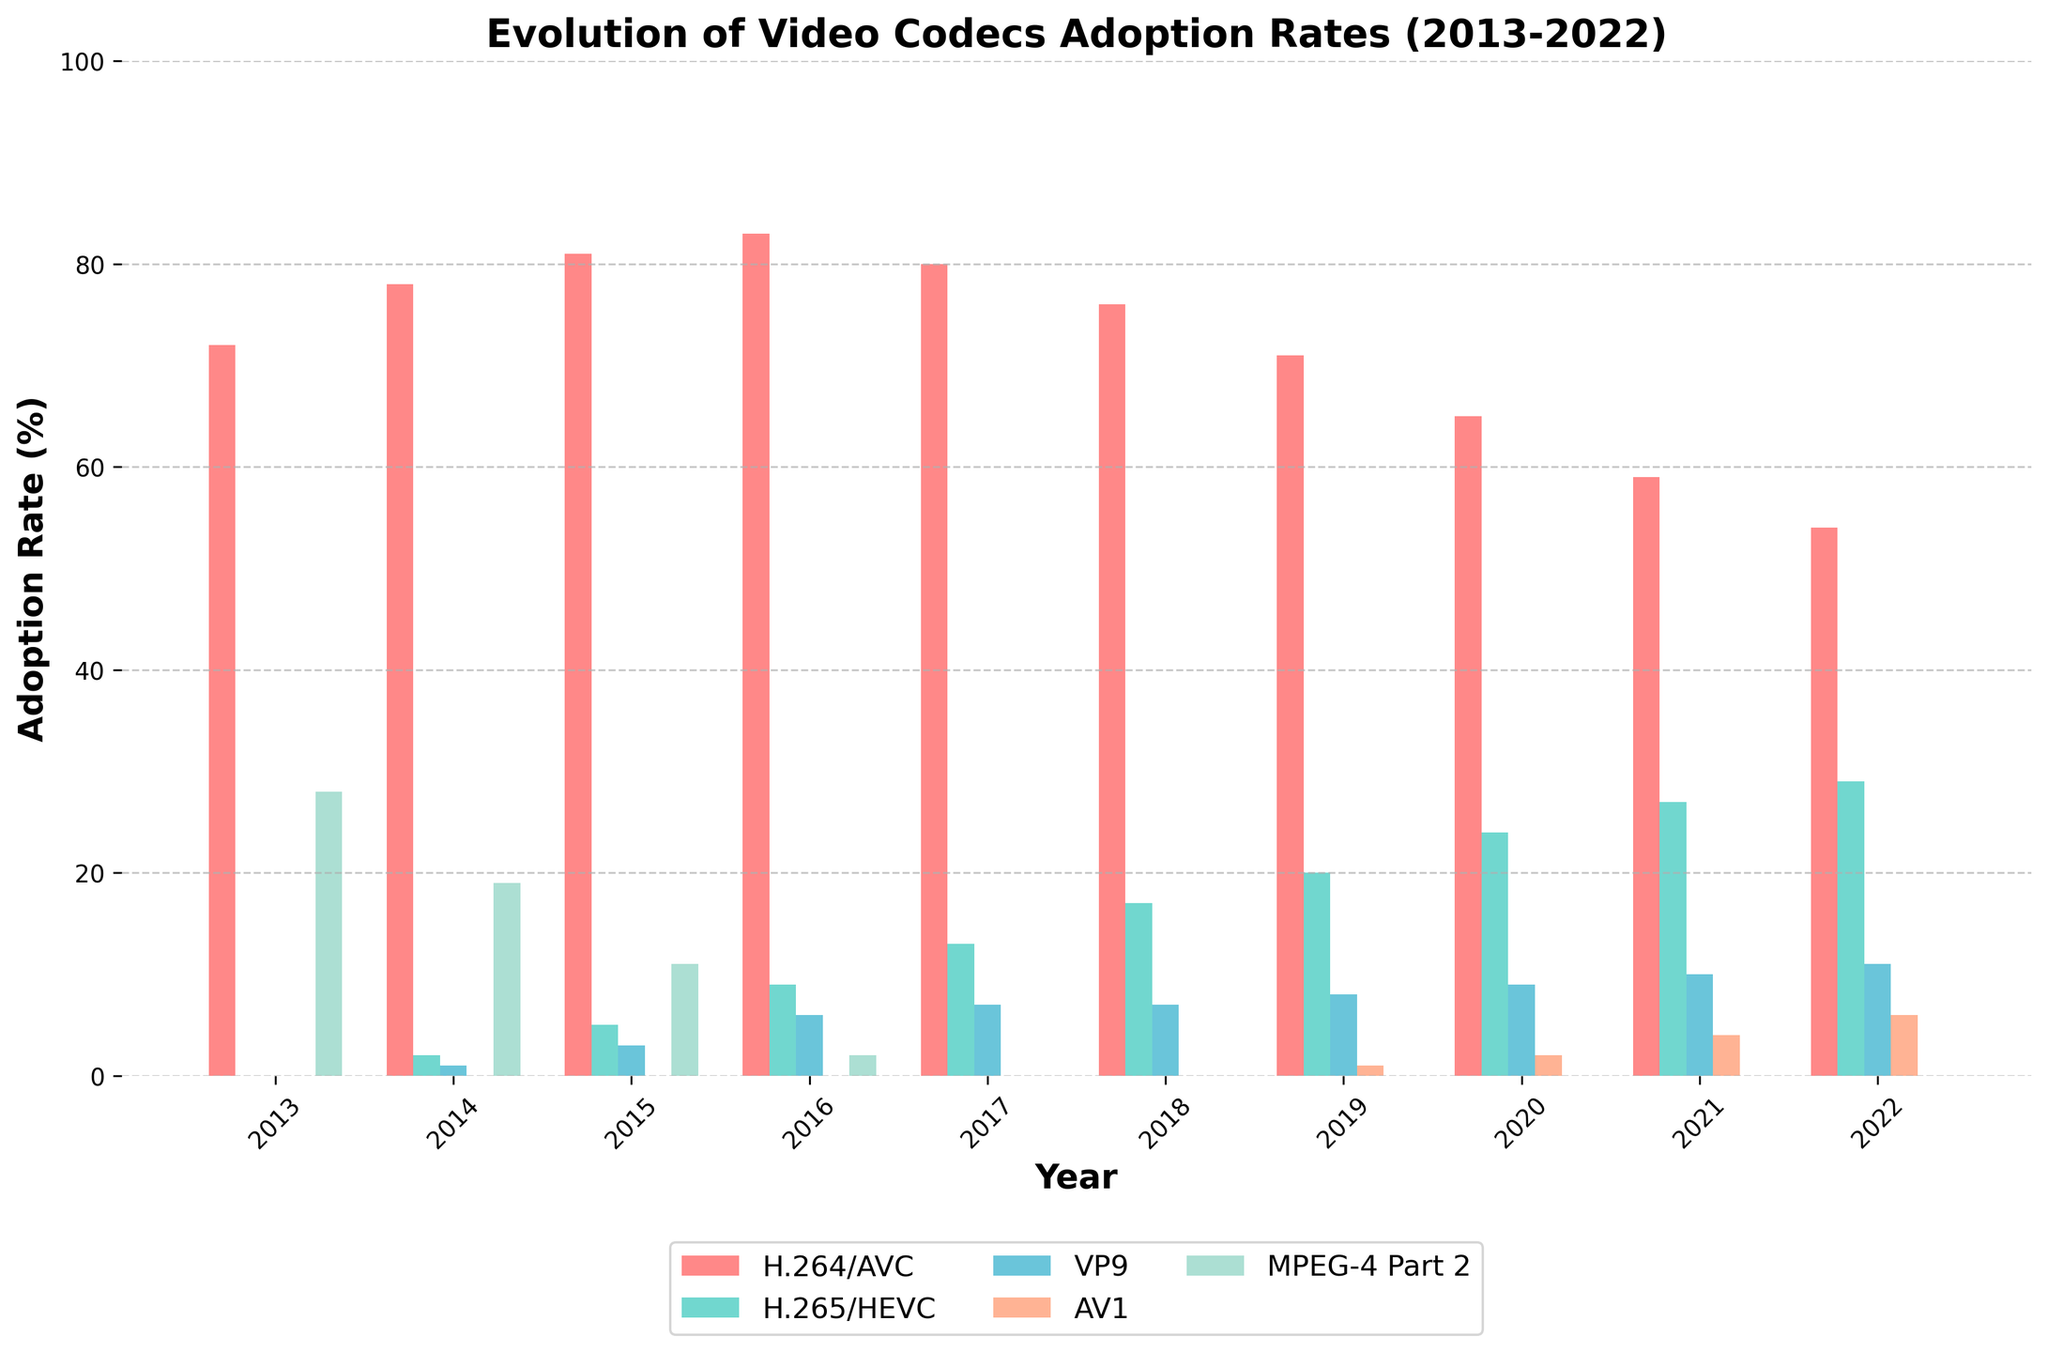Which codec had the highest adoption rate in 2022? By examining the height of the bars for the year 2022, the tallest bar represents H.264/AVC.
Answer: H.264/AVC How did the adoption rate of H.264/AVC change from 2013 to 2022? The adoption rate of H.264/AVC decreased from 72% in 2013 to 54% in 2022.
Answer: Decreased What is the total adoption rate of all codecs in 2017? Sum the adoption rates of H.264/AVC (80%), H.265/HEVC (13%), VP9 (7%), AV1 (0%), and MPEG-4 Part 2 (0%) in 2017. The total is 80% + 13% + 7% + 0% + 0% = 100%.
Answer: 100% Which year showed the first appearance of AV1? AV1 first appears with a 1% adoption rate in 2019.
Answer: 2019 Compare the adoption rates of H.265/HEVC and VP9 in 2022. Which is higher? In 2022, the adoption rate for H.265/HEVC is 29%, whereas for VP9 it is 11%. H.265/HEVC is higher.
Answer: H.265/HEVC What is the average adoption rate of H.264/AVC over the decade? Add the adoption rates of H.264/AVC from 2013 to 2022 and divide by 10. (72% + 78% + 81% + 83% + 80% + 76% + 71% + 65% + 59% + 54%) / 10 = 71.9%.
Answer: 71.9% By how much did the adoption rate of MPEG-4 Part 2 decrease from 2013 to 2016? The adoption rate of MPEG-4 Part 2 was 28% in 2013 and dropped to 2% in 2016. The decrease is 28% - 2% = 26%.
Answer: 26% Which codec experienced the highest increase in adoption rate between 2019 and 2022? The increase in adoption rates between 2019 and 2022 are: H.264/AVC: 71% to 54% (-17%), H.265/HEVC: 20% to 29% (+9%), VP9: 8% to 11% (+3%), AV1: 1% to 6% (+5%). The highest increase is of H.265/HEVC with +9%.
Answer: H.265/HEVC What color represents VP9 in the chart? Observing the bars for VP9 across the years, they are represented by the blue bars.
Answer: Blue Is there any year where three codecs had an adoption rate of 0%? If yes, which year? By examining the chart carefully, 2013 is the year where H.265/HEVC, VP9, and AV1 each had an adoption rate of 0%.
Answer: 2013 